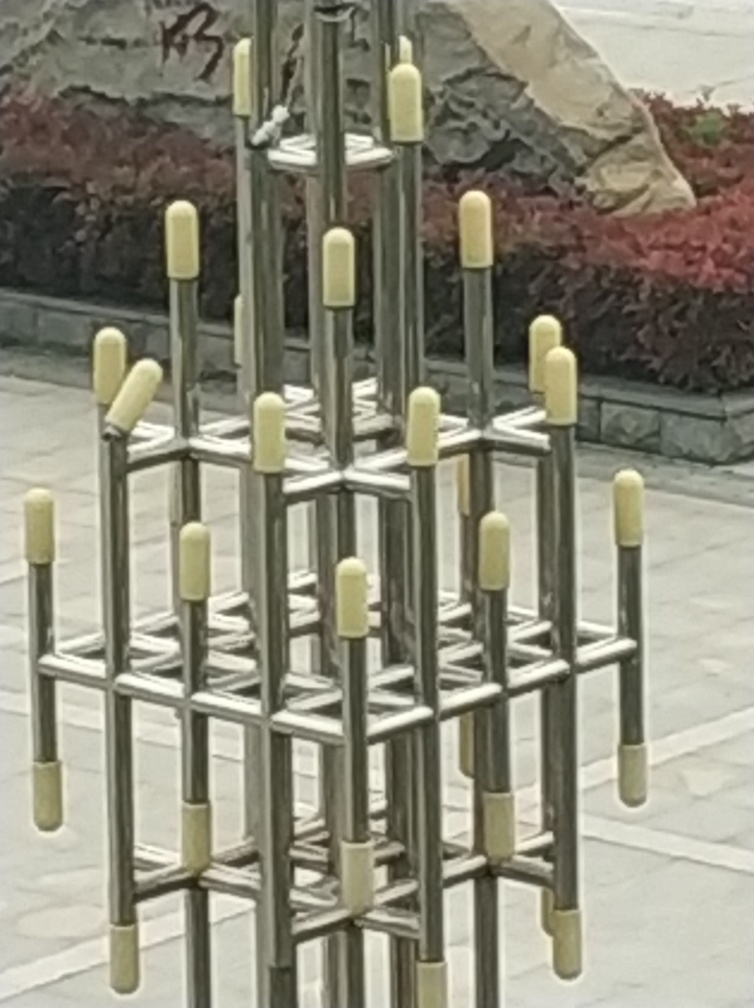Can you describe the texture and color schemes observable in the scene? The scene is dominated by the metallic texture of the sculpture, which gives a sense of industrial sleekness with its shiny and smooth surface. The color scheme is relatively muted, consisting of the metallic grey of the structure and soft hues of green and purplish-red from the plants in the background, suggesting it’s either late in the season or a type of foliage that changes color.  Does the environment suggest a specific location or setting? The image seems to show an urban or park setting, as indicated by the manicured plants and bushes in the background. The style of the sculpture could suggest a modern space, possibly within a corporate area, public park, or an outdoor exhibit space of a museum or gallery. 